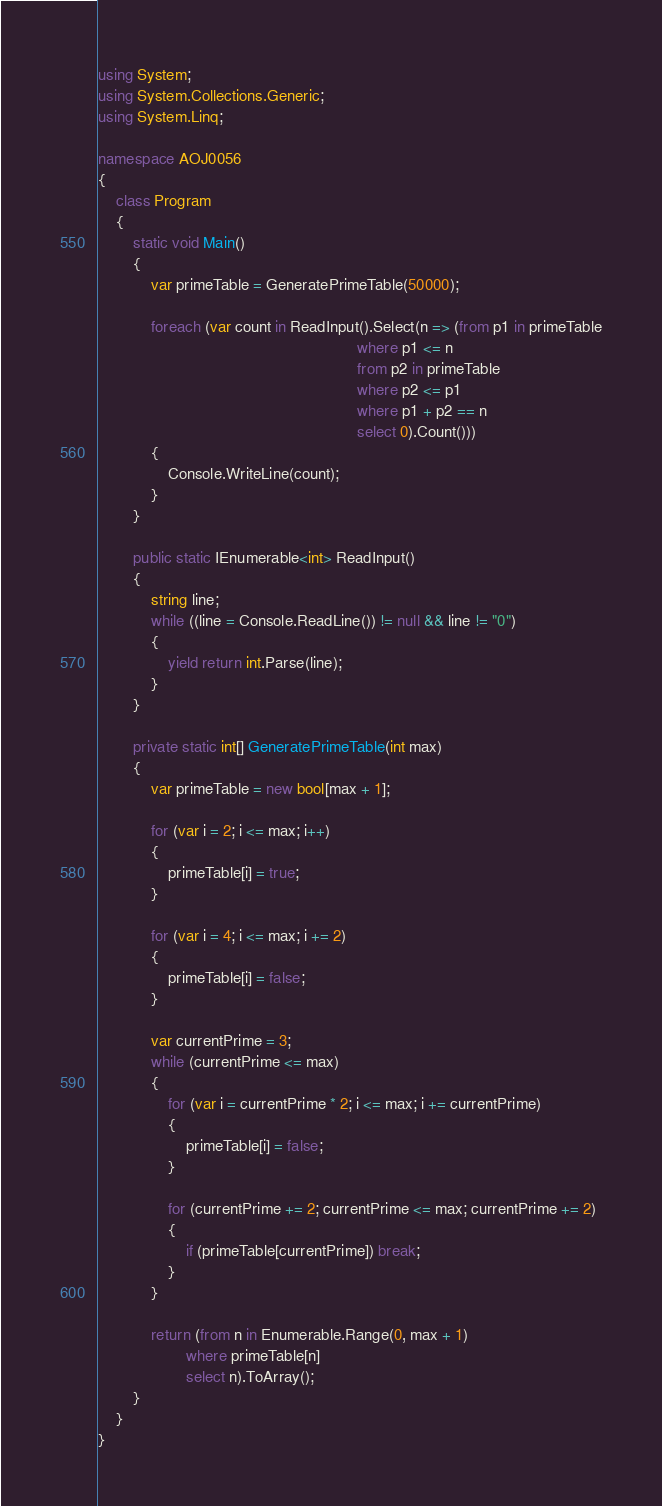Convert code to text. <code><loc_0><loc_0><loc_500><loc_500><_C#_>using System;
using System.Collections.Generic;
using System.Linq;

namespace AOJ0056
{
    class Program
    {
        static void Main()
        {
            var primeTable = GeneratePrimeTable(50000);

            foreach (var count in ReadInput().Select(n => (from p1 in primeTable
                                                           where p1 <= n
                                                           from p2 in primeTable
                                                           where p2 <= p1
                                                           where p1 + p2 == n
                                                           select 0).Count()))
            {
                Console.WriteLine(count);
            }
        }

        public static IEnumerable<int> ReadInput()
        {
            string line;
            while ((line = Console.ReadLine()) != null && line != "0")
            {
                yield return int.Parse(line);
            }
        }

        private static int[] GeneratePrimeTable(int max)
        {
            var primeTable = new bool[max + 1];

            for (var i = 2; i <= max; i++)
            {
                primeTable[i] = true;
            }

            for (var i = 4; i <= max; i += 2)
            {
                primeTable[i] = false;
            }

            var currentPrime = 3;
            while (currentPrime <= max)
            {
                for (var i = currentPrime * 2; i <= max; i += currentPrime)
                {
                    primeTable[i] = false;
                }

                for (currentPrime += 2; currentPrime <= max; currentPrime += 2)
                {
                    if (primeTable[currentPrime]) break;
                }
            }

            return (from n in Enumerable.Range(0, max + 1)
                    where primeTable[n]
                    select n).ToArray();
        }
    }
}</code> 